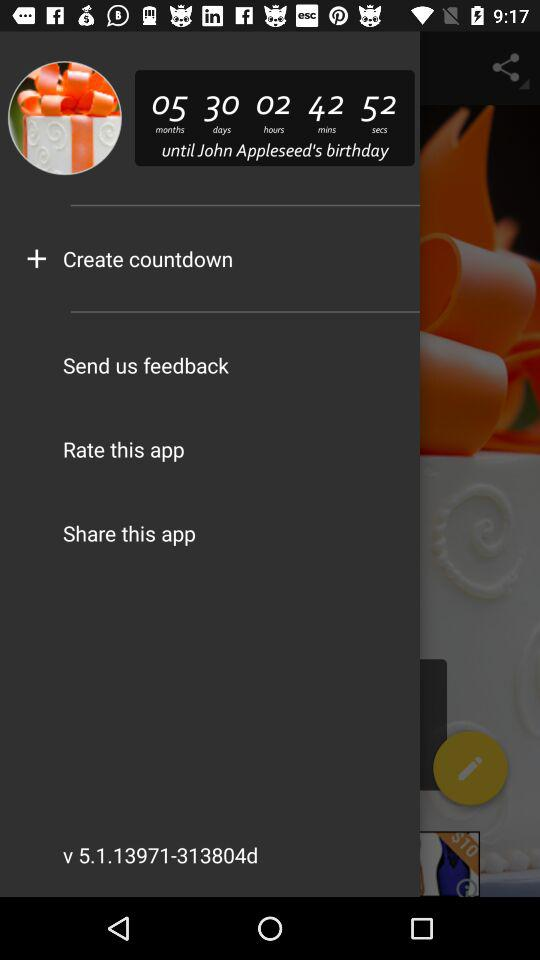How many months are left until John Appleseed's birthday? There are five months left. 